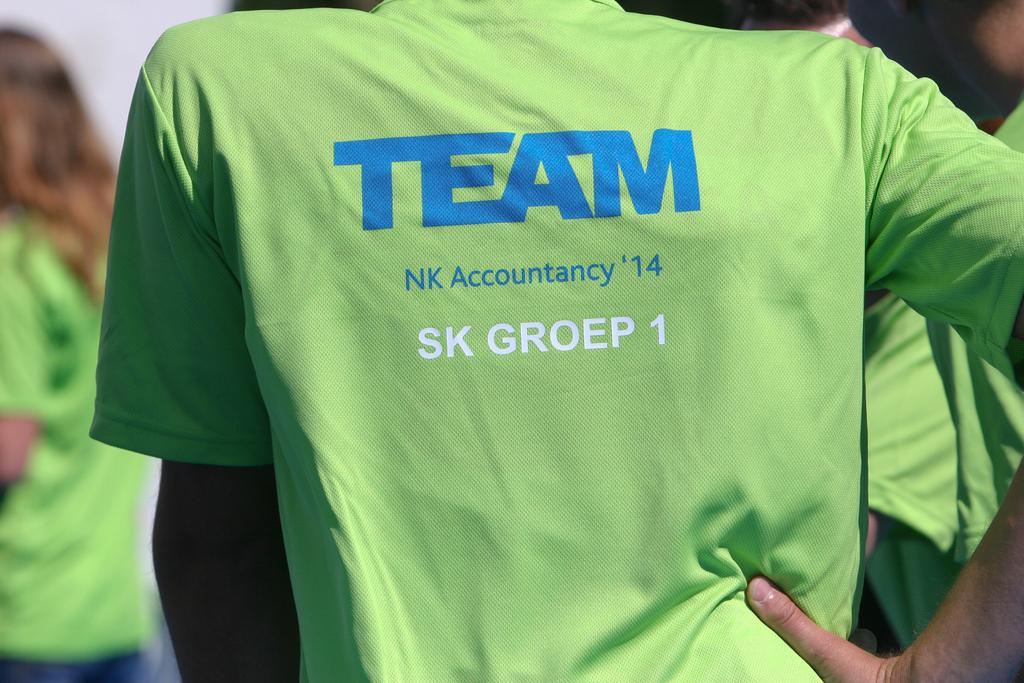<image>
Describe the image concisely. A green shirt that says "Team" and "SK Groep 1" on it. 